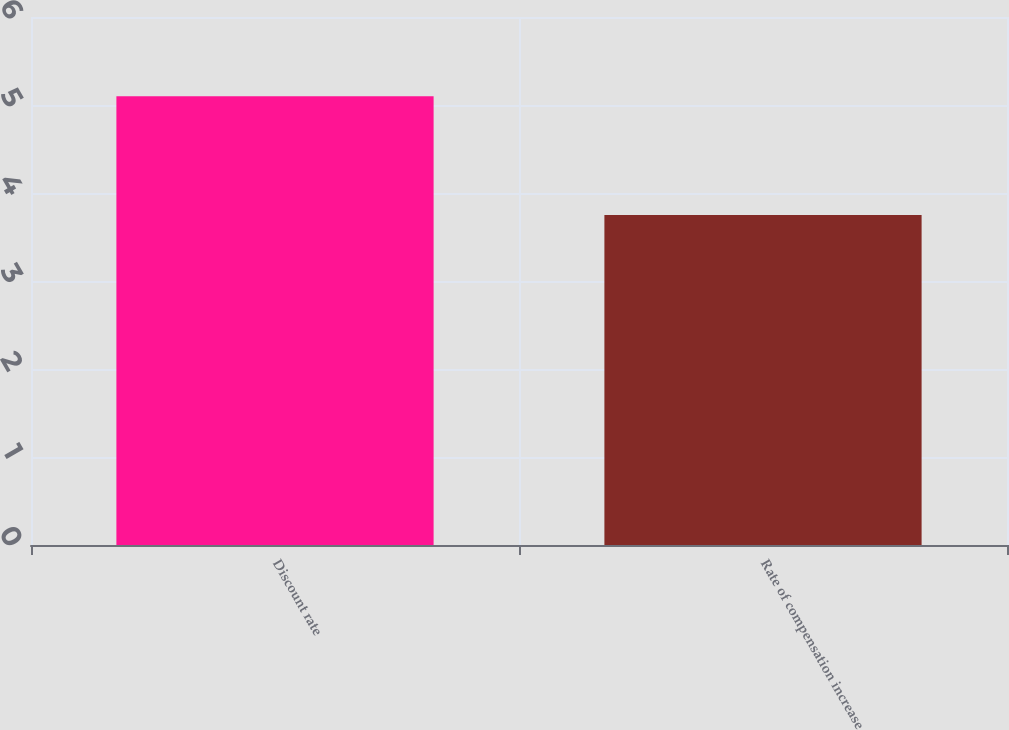Convert chart. <chart><loc_0><loc_0><loc_500><loc_500><bar_chart><fcel>Discount rate<fcel>Rate of compensation increase<nl><fcel>5.1<fcel>3.75<nl></chart> 